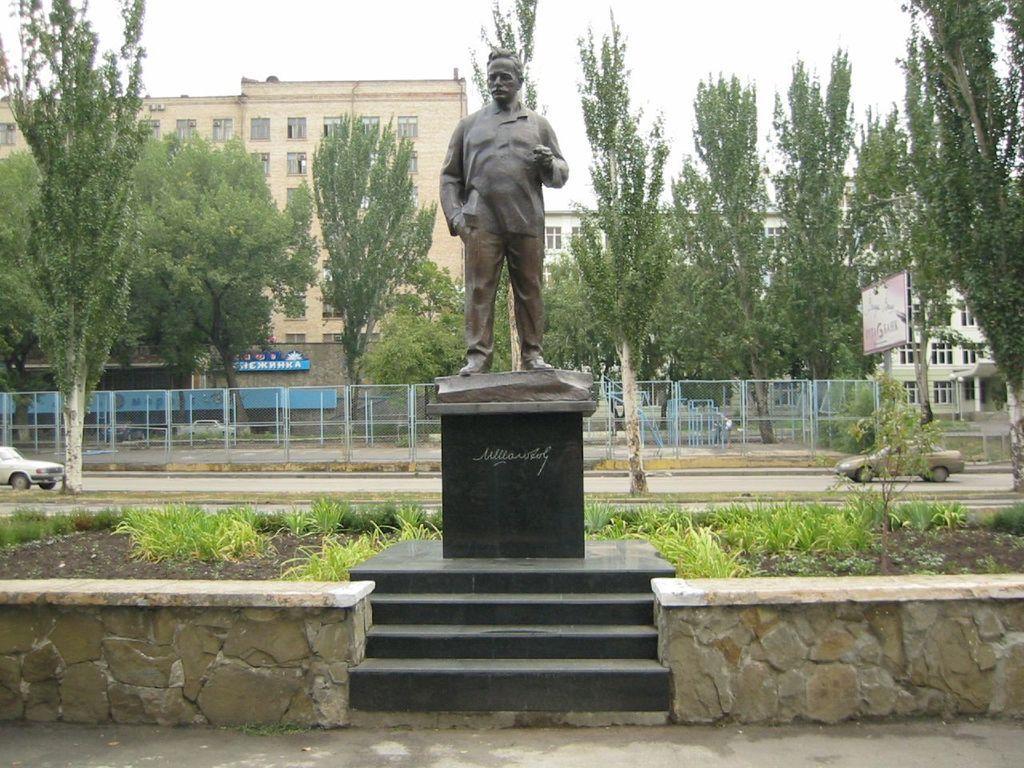Describe this image in one or two sentences. In this image we can see a statue, there are cars parked on road, fence, a group of trees, sign boards with text. In the foreground we can see group of plants. In the background, we can see a group of buildings, staircase and the sky. 